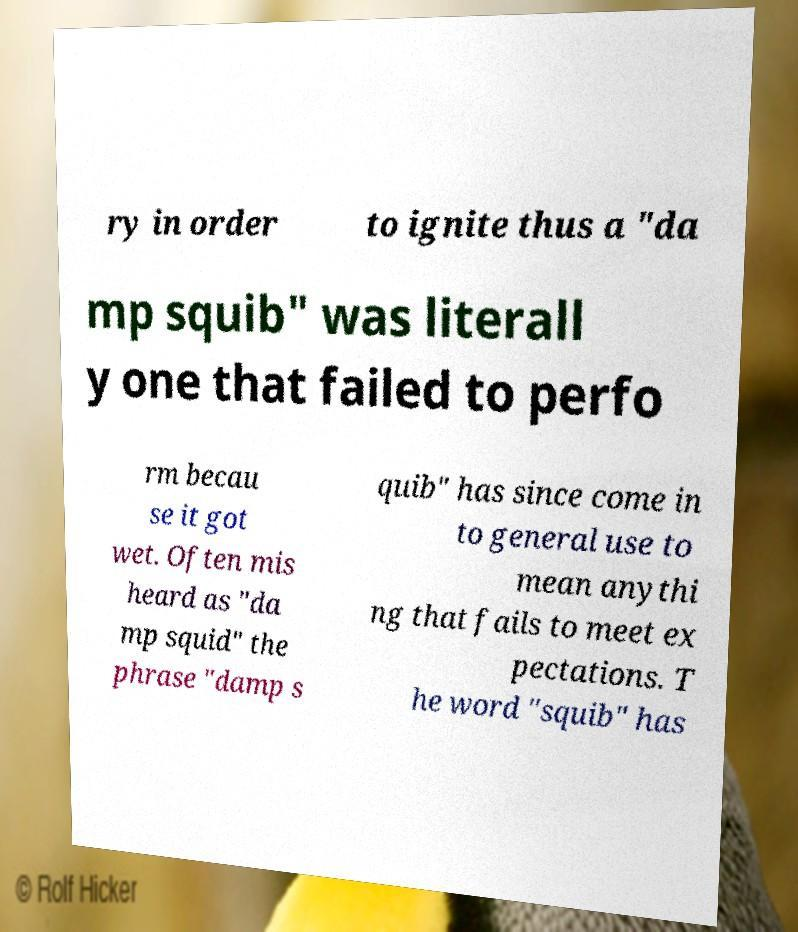Can you accurately transcribe the text from the provided image for me? ry in order to ignite thus a "da mp squib" was literall y one that failed to perfo rm becau se it got wet. Often mis heard as "da mp squid" the phrase "damp s quib" has since come in to general use to mean anythi ng that fails to meet ex pectations. T he word "squib" has 